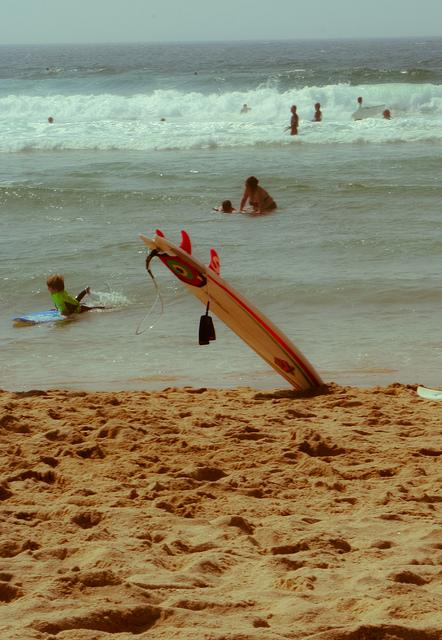What is in the sand?

Choices:
A) baby
B) cat
C) old man
D) surfboard surfboard 